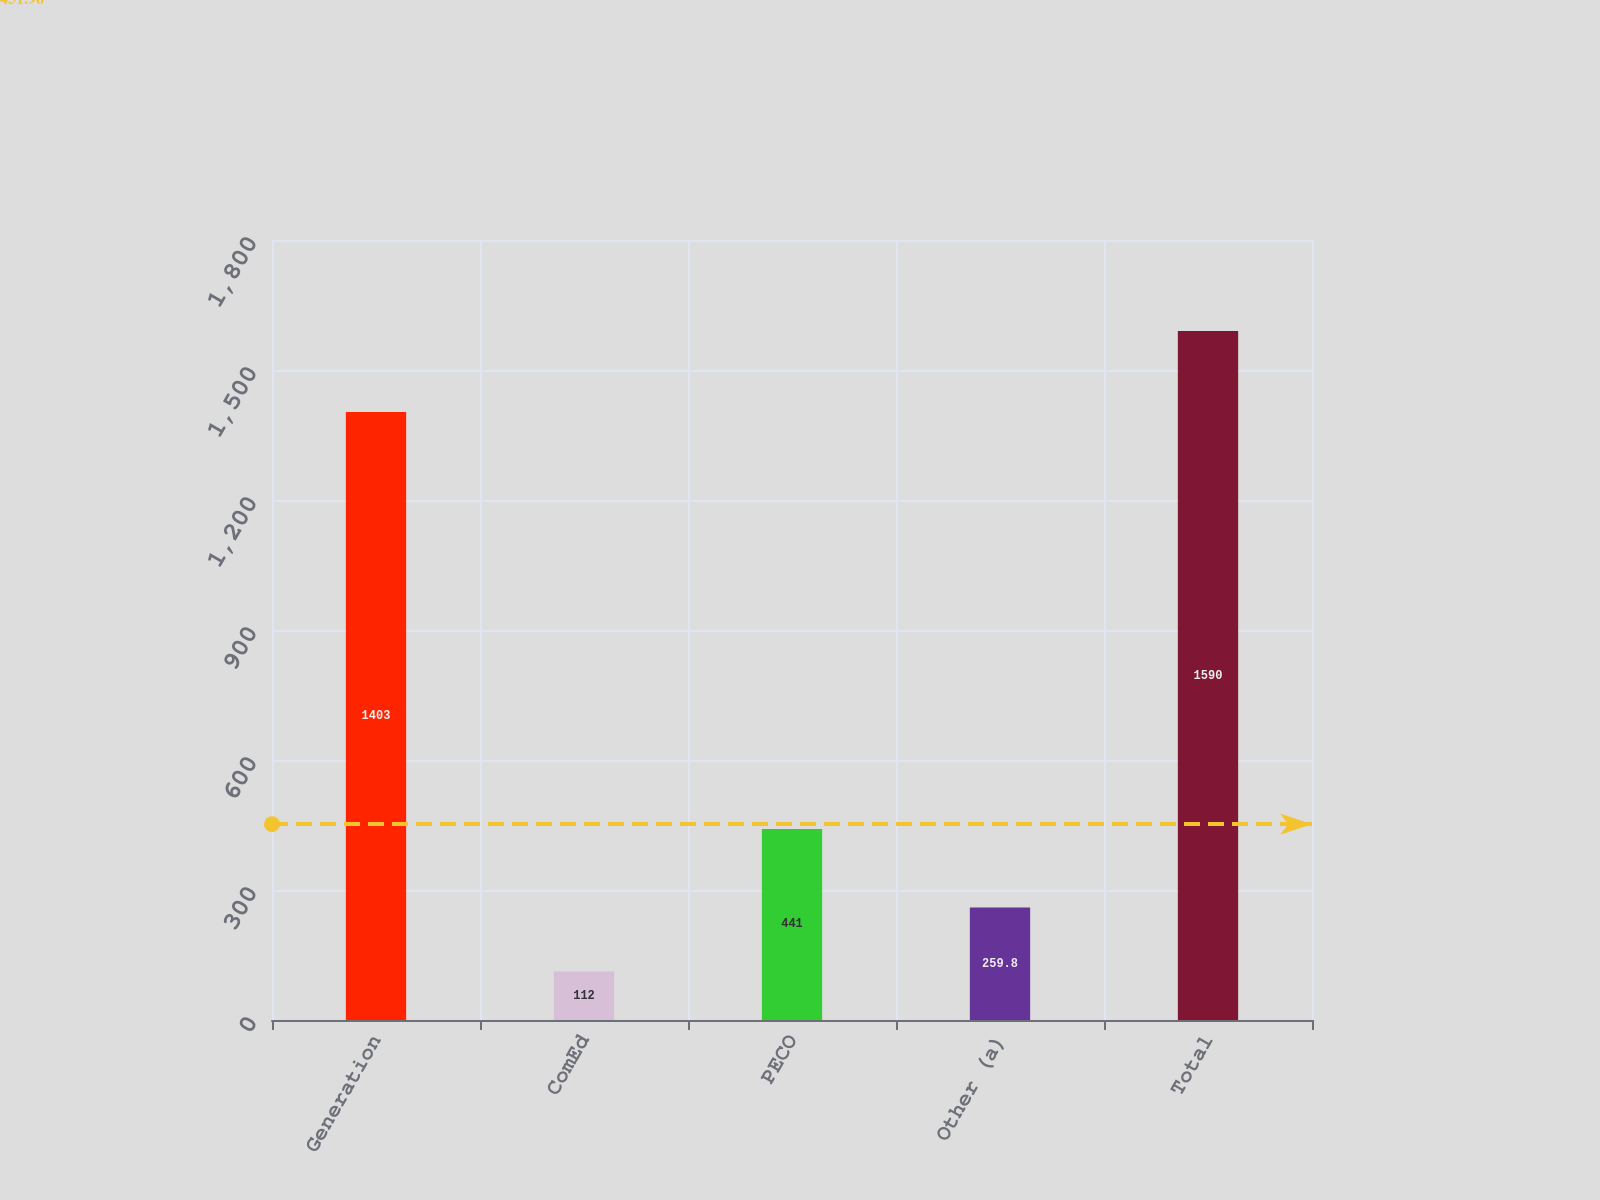Convert chart to OTSL. <chart><loc_0><loc_0><loc_500><loc_500><bar_chart><fcel>Generation<fcel>ComEd<fcel>PECO<fcel>Other (a)<fcel>Total<nl><fcel>1403<fcel>112<fcel>441<fcel>259.8<fcel>1590<nl></chart> 